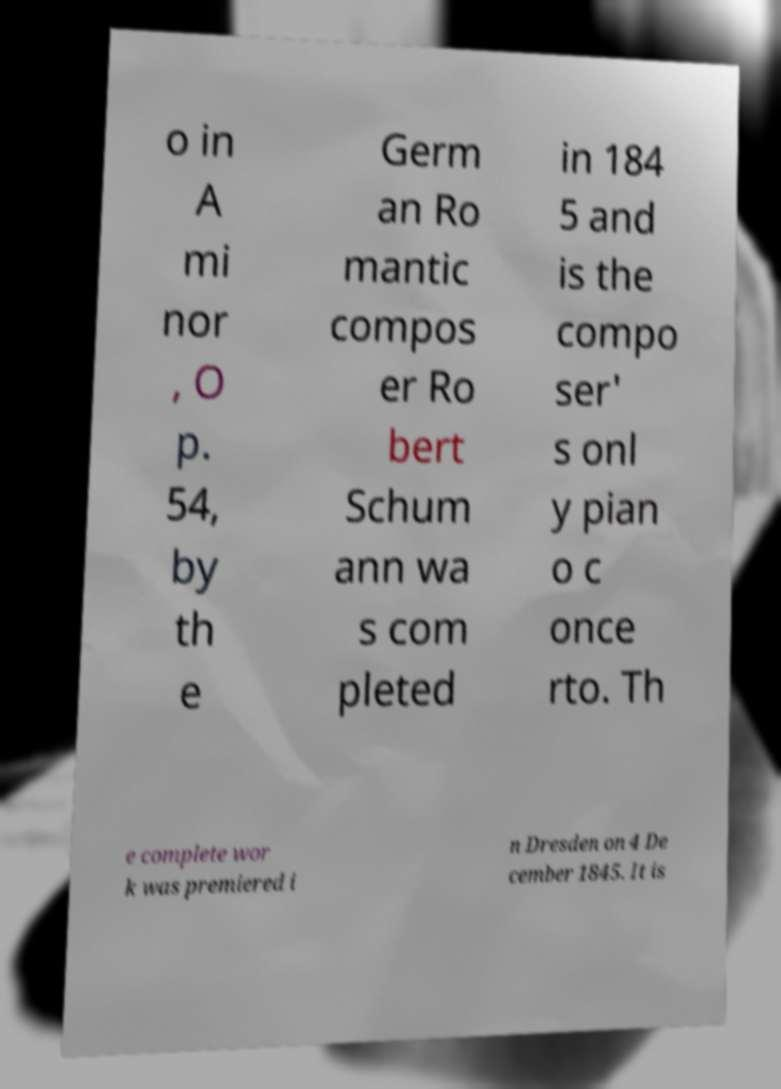What messages or text are displayed in this image? I need them in a readable, typed format. o in A mi nor , O p. 54, by th e Germ an Ro mantic compos er Ro bert Schum ann wa s com pleted in 184 5 and is the compo ser' s onl y pian o c once rto. Th e complete wor k was premiered i n Dresden on 4 De cember 1845. It is 